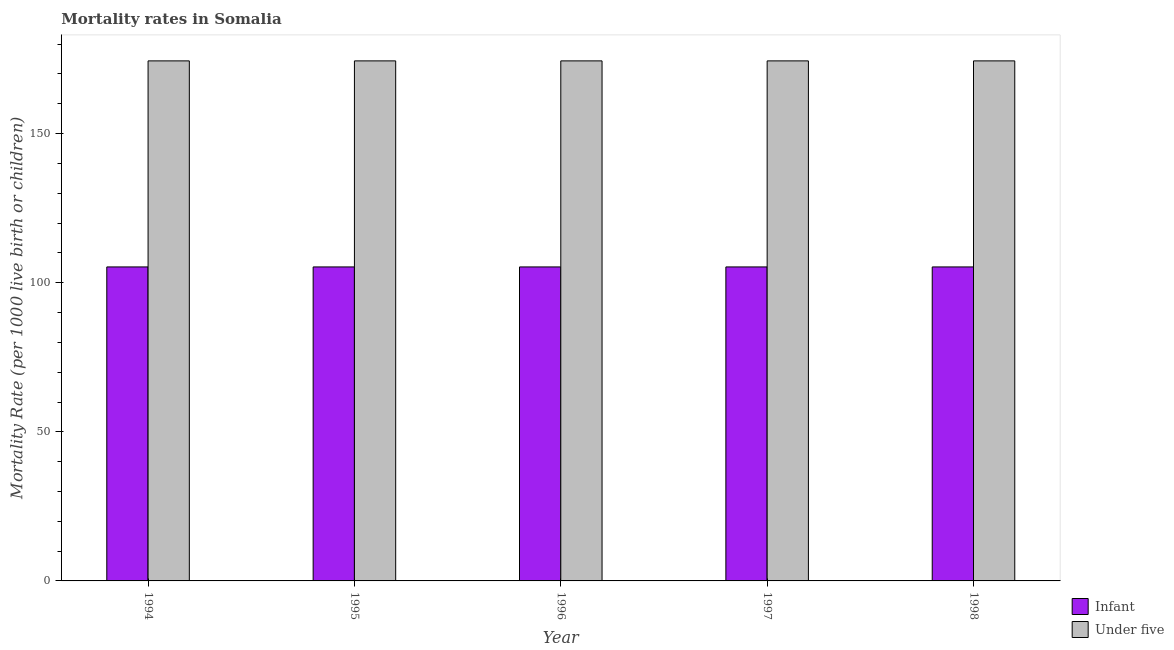How many groups of bars are there?
Keep it short and to the point. 5. Are the number of bars per tick equal to the number of legend labels?
Give a very brief answer. Yes. Are the number of bars on each tick of the X-axis equal?
Provide a short and direct response. Yes. How many bars are there on the 1st tick from the left?
Keep it short and to the point. 2. What is the label of the 1st group of bars from the left?
Your answer should be compact. 1994. What is the under-5 mortality rate in 1997?
Offer a very short reply. 174.4. Across all years, what is the maximum under-5 mortality rate?
Make the answer very short. 174.4. Across all years, what is the minimum infant mortality rate?
Provide a short and direct response. 105.3. In which year was the under-5 mortality rate maximum?
Make the answer very short. 1994. What is the total under-5 mortality rate in the graph?
Your response must be concise. 872. What is the average under-5 mortality rate per year?
Provide a succinct answer. 174.4. In how many years, is the under-5 mortality rate greater than 130?
Provide a succinct answer. 5. What is the ratio of the infant mortality rate in 1995 to that in 1998?
Make the answer very short. 1. Is the infant mortality rate in 1996 less than that in 1998?
Your answer should be very brief. No. In how many years, is the under-5 mortality rate greater than the average under-5 mortality rate taken over all years?
Your answer should be very brief. 0. Is the sum of the infant mortality rate in 1994 and 1997 greater than the maximum under-5 mortality rate across all years?
Provide a succinct answer. Yes. What does the 2nd bar from the left in 1995 represents?
Provide a succinct answer. Under five. What does the 2nd bar from the right in 1995 represents?
Offer a terse response. Infant. Are all the bars in the graph horizontal?
Offer a very short reply. No. Does the graph contain any zero values?
Your response must be concise. No. What is the title of the graph?
Provide a short and direct response. Mortality rates in Somalia. What is the label or title of the X-axis?
Provide a short and direct response. Year. What is the label or title of the Y-axis?
Ensure brevity in your answer.  Mortality Rate (per 1000 live birth or children). What is the Mortality Rate (per 1000 live birth or children) in Infant in 1994?
Offer a terse response. 105.3. What is the Mortality Rate (per 1000 live birth or children) in Under five in 1994?
Provide a short and direct response. 174.4. What is the Mortality Rate (per 1000 live birth or children) in Infant in 1995?
Provide a succinct answer. 105.3. What is the Mortality Rate (per 1000 live birth or children) in Under five in 1995?
Your response must be concise. 174.4. What is the Mortality Rate (per 1000 live birth or children) of Infant in 1996?
Ensure brevity in your answer.  105.3. What is the Mortality Rate (per 1000 live birth or children) of Under five in 1996?
Offer a terse response. 174.4. What is the Mortality Rate (per 1000 live birth or children) in Infant in 1997?
Give a very brief answer. 105.3. What is the Mortality Rate (per 1000 live birth or children) of Under five in 1997?
Provide a short and direct response. 174.4. What is the Mortality Rate (per 1000 live birth or children) of Infant in 1998?
Offer a very short reply. 105.3. What is the Mortality Rate (per 1000 live birth or children) of Under five in 1998?
Give a very brief answer. 174.4. Across all years, what is the maximum Mortality Rate (per 1000 live birth or children) in Infant?
Make the answer very short. 105.3. Across all years, what is the maximum Mortality Rate (per 1000 live birth or children) in Under five?
Ensure brevity in your answer.  174.4. Across all years, what is the minimum Mortality Rate (per 1000 live birth or children) in Infant?
Make the answer very short. 105.3. Across all years, what is the minimum Mortality Rate (per 1000 live birth or children) of Under five?
Your answer should be compact. 174.4. What is the total Mortality Rate (per 1000 live birth or children) in Infant in the graph?
Provide a succinct answer. 526.5. What is the total Mortality Rate (per 1000 live birth or children) of Under five in the graph?
Your answer should be very brief. 872. What is the difference between the Mortality Rate (per 1000 live birth or children) of Infant in 1994 and that in 1995?
Provide a succinct answer. 0. What is the difference between the Mortality Rate (per 1000 live birth or children) in Under five in 1994 and that in 1995?
Make the answer very short. 0. What is the difference between the Mortality Rate (per 1000 live birth or children) in Infant in 1994 and that in 1996?
Keep it short and to the point. 0. What is the difference between the Mortality Rate (per 1000 live birth or children) in Under five in 1994 and that in 1998?
Your response must be concise. 0. What is the difference between the Mortality Rate (per 1000 live birth or children) of Infant in 1995 and that in 1996?
Offer a very short reply. 0. What is the difference between the Mortality Rate (per 1000 live birth or children) of Under five in 1995 and that in 1998?
Give a very brief answer. 0. What is the difference between the Mortality Rate (per 1000 live birth or children) of Infant in 1996 and that in 1997?
Your answer should be very brief. 0. What is the difference between the Mortality Rate (per 1000 live birth or children) of Infant in 1996 and that in 1998?
Ensure brevity in your answer.  0. What is the difference between the Mortality Rate (per 1000 live birth or children) in Under five in 1997 and that in 1998?
Make the answer very short. 0. What is the difference between the Mortality Rate (per 1000 live birth or children) in Infant in 1994 and the Mortality Rate (per 1000 live birth or children) in Under five in 1995?
Offer a terse response. -69.1. What is the difference between the Mortality Rate (per 1000 live birth or children) in Infant in 1994 and the Mortality Rate (per 1000 live birth or children) in Under five in 1996?
Give a very brief answer. -69.1. What is the difference between the Mortality Rate (per 1000 live birth or children) in Infant in 1994 and the Mortality Rate (per 1000 live birth or children) in Under five in 1997?
Your answer should be very brief. -69.1. What is the difference between the Mortality Rate (per 1000 live birth or children) in Infant in 1994 and the Mortality Rate (per 1000 live birth or children) in Under five in 1998?
Give a very brief answer. -69.1. What is the difference between the Mortality Rate (per 1000 live birth or children) in Infant in 1995 and the Mortality Rate (per 1000 live birth or children) in Under five in 1996?
Give a very brief answer. -69.1. What is the difference between the Mortality Rate (per 1000 live birth or children) of Infant in 1995 and the Mortality Rate (per 1000 live birth or children) of Under five in 1997?
Ensure brevity in your answer.  -69.1. What is the difference between the Mortality Rate (per 1000 live birth or children) in Infant in 1995 and the Mortality Rate (per 1000 live birth or children) in Under five in 1998?
Make the answer very short. -69.1. What is the difference between the Mortality Rate (per 1000 live birth or children) of Infant in 1996 and the Mortality Rate (per 1000 live birth or children) of Under five in 1997?
Offer a very short reply. -69.1. What is the difference between the Mortality Rate (per 1000 live birth or children) of Infant in 1996 and the Mortality Rate (per 1000 live birth or children) of Under five in 1998?
Provide a succinct answer. -69.1. What is the difference between the Mortality Rate (per 1000 live birth or children) in Infant in 1997 and the Mortality Rate (per 1000 live birth or children) in Under five in 1998?
Provide a short and direct response. -69.1. What is the average Mortality Rate (per 1000 live birth or children) of Infant per year?
Your answer should be compact. 105.3. What is the average Mortality Rate (per 1000 live birth or children) in Under five per year?
Give a very brief answer. 174.4. In the year 1994, what is the difference between the Mortality Rate (per 1000 live birth or children) of Infant and Mortality Rate (per 1000 live birth or children) of Under five?
Ensure brevity in your answer.  -69.1. In the year 1995, what is the difference between the Mortality Rate (per 1000 live birth or children) of Infant and Mortality Rate (per 1000 live birth or children) of Under five?
Your answer should be compact. -69.1. In the year 1996, what is the difference between the Mortality Rate (per 1000 live birth or children) in Infant and Mortality Rate (per 1000 live birth or children) in Under five?
Provide a succinct answer. -69.1. In the year 1997, what is the difference between the Mortality Rate (per 1000 live birth or children) in Infant and Mortality Rate (per 1000 live birth or children) in Under five?
Provide a short and direct response. -69.1. In the year 1998, what is the difference between the Mortality Rate (per 1000 live birth or children) in Infant and Mortality Rate (per 1000 live birth or children) in Under five?
Your answer should be compact. -69.1. What is the ratio of the Mortality Rate (per 1000 live birth or children) of Infant in 1994 to that in 1995?
Provide a short and direct response. 1. What is the ratio of the Mortality Rate (per 1000 live birth or children) in Under five in 1994 to that in 1995?
Make the answer very short. 1. What is the ratio of the Mortality Rate (per 1000 live birth or children) of Infant in 1994 to that in 1996?
Provide a short and direct response. 1. What is the ratio of the Mortality Rate (per 1000 live birth or children) of Infant in 1995 to that in 1996?
Offer a very short reply. 1. What is the ratio of the Mortality Rate (per 1000 live birth or children) in Infant in 1995 to that in 1997?
Keep it short and to the point. 1. What is the ratio of the Mortality Rate (per 1000 live birth or children) of Infant in 1995 to that in 1998?
Give a very brief answer. 1. What is the ratio of the Mortality Rate (per 1000 live birth or children) of Infant in 1996 to that in 1997?
Your answer should be compact. 1. What is the ratio of the Mortality Rate (per 1000 live birth or children) in Under five in 1997 to that in 1998?
Make the answer very short. 1. What is the difference between the highest and the second highest Mortality Rate (per 1000 live birth or children) in Under five?
Provide a succinct answer. 0. What is the difference between the highest and the lowest Mortality Rate (per 1000 live birth or children) of Infant?
Keep it short and to the point. 0. 